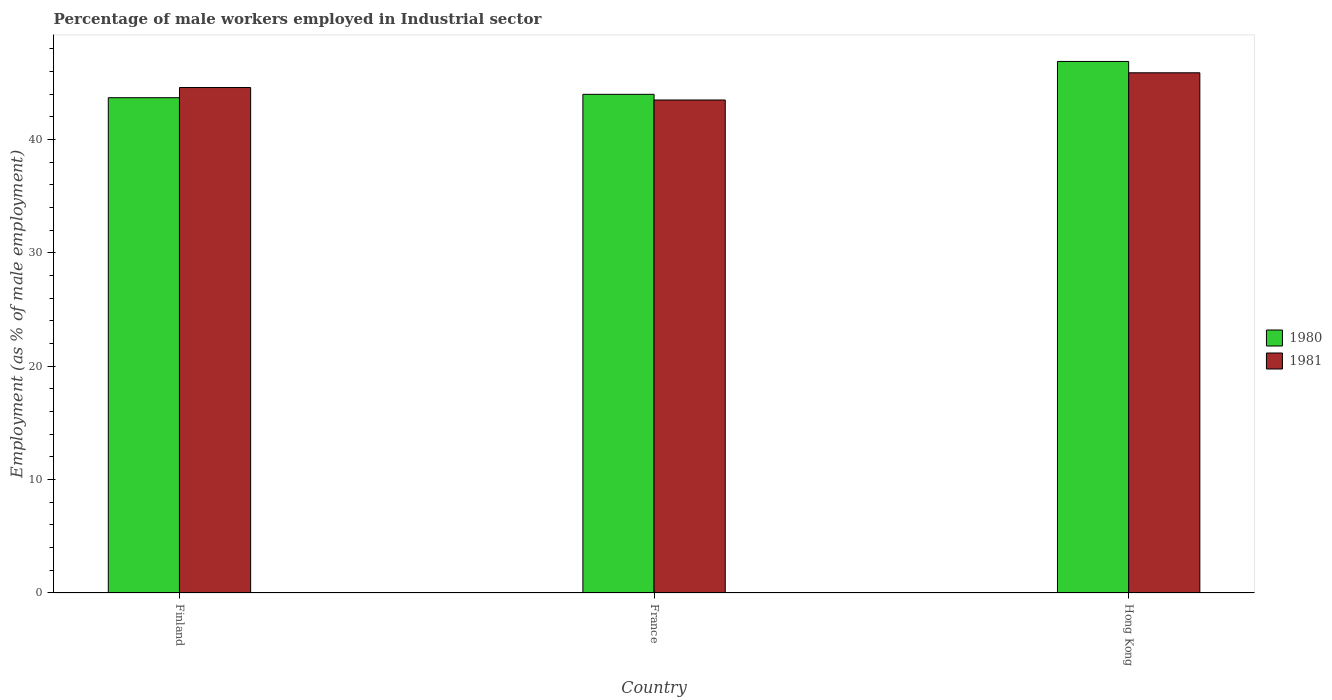How many groups of bars are there?
Your response must be concise. 3. Are the number of bars on each tick of the X-axis equal?
Your answer should be very brief. Yes. How many bars are there on the 3rd tick from the right?
Provide a succinct answer. 2. In how many cases, is the number of bars for a given country not equal to the number of legend labels?
Ensure brevity in your answer.  0. Across all countries, what is the maximum percentage of male workers employed in Industrial sector in 1981?
Offer a very short reply. 45.9. Across all countries, what is the minimum percentage of male workers employed in Industrial sector in 1980?
Your answer should be very brief. 43.7. In which country was the percentage of male workers employed in Industrial sector in 1981 maximum?
Your answer should be compact. Hong Kong. What is the total percentage of male workers employed in Industrial sector in 1980 in the graph?
Keep it short and to the point. 134.6. What is the difference between the percentage of male workers employed in Industrial sector in 1980 in France and that in Hong Kong?
Your response must be concise. -2.9. What is the difference between the percentage of male workers employed in Industrial sector in 1980 in France and the percentage of male workers employed in Industrial sector in 1981 in Finland?
Ensure brevity in your answer.  -0.6. What is the average percentage of male workers employed in Industrial sector in 1981 per country?
Your response must be concise. 44.67. What is the difference between the percentage of male workers employed in Industrial sector of/in 1980 and percentage of male workers employed in Industrial sector of/in 1981 in France?
Offer a very short reply. 0.5. In how many countries, is the percentage of male workers employed in Industrial sector in 1981 greater than 16 %?
Provide a succinct answer. 3. What is the ratio of the percentage of male workers employed in Industrial sector in 1981 in France to that in Hong Kong?
Your answer should be very brief. 0.95. What is the difference between the highest and the second highest percentage of male workers employed in Industrial sector in 1981?
Make the answer very short. -1.1. What is the difference between the highest and the lowest percentage of male workers employed in Industrial sector in 1980?
Offer a very short reply. 3.2. What does the 1st bar from the right in Finland represents?
Make the answer very short. 1981. How many bars are there?
Ensure brevity in your answer.  6. How many countries are there in the graph?
Ensure brevity in your answer.  3. What is the difference between two consecutive major ticks on the Y-axis?
Ensure brevity in your answer.  10. Are the values on the major ticks of Y-axis written in scientific E-notation?
Your answer should be compact. No. Does the graph contain grids?
Offer a very short reply. No. Where does the legend appear in the graph?
Provide a succinct answer. Center right. How many legend labels are there?
Give a very brief answer. 2. What is the title of the graph?
Your response must be concise. Percentage of male workers employed in Industrial sector. What is the label or title of the X-axis?
Offer a very short reply. Country. What is the label or title of the Y-axis?
Your answer should be compact. Employment (as % of male employment). What is the Employment (as % of male employment) of 1980 in Finland?
Give a very brief answer. 43.7. What is the Employment (as % of male employment) in 1981 in Finland?
Your answer should be very brief. 44.6. What is the Employment (as % of male employment) of 1980 in France?
Your answer should be very brief. 44. What is the Employment (as % of male employment) of 1981 in France?
Your answer should be very brief. 43.5. What is the Employment (as % of male employment) in 1980 in Hong Kong?
Your response must be concise. 46.9. What is the Employment (as % of male employment) of 1981 in Hong Kong?
Your answer should be very brief. 45.9. Across all countries, what is the maximum Employment (as % of male employment) in 1980?
Provide a short and direct response. 46.9. Across all countries, what is the maximum Employment (as % of male employment) of 1981?
Your answer should be compact. 45.9. Across all countries, what is the minimum Employment (as % of male employment) of 1980?
Keep it short and to the point. 43.7. Across all countries, what is the minimum Employment (as % of male employment) of 1981?
Offer a terse response. 43.5. What is the total Employment (as % of male employment) of 1980 in the graph?
Make the answer very short. 134.6. What is the total Employment (as % of male employment) of 1981 in the graph?
Make the answer very short. 134. What is the difference between the Employment (as % of male employment) of 1980 in Finland and that in France?
Provide a short and direct response. -0.3. What is the difference between the Employment (as % of male employment) in 1981 in Finland and that in France?
Your answer should be very brief. 1.1. What is the difference between the Employment (as % of male employment) of 1980 in Finland and that in Hong Kong?
Your answer should be compact. -3.2. What is the difference between the Employment (as % of male employment) in 1980 in Finland and the Employment (as % of male employment) in 1981 in France?
Offer a terse response. 0.2. What is the average Employment (as % of male employment) in 1980 per country?
Keep it short and to the point. 44.87. What is the average Employment (as % of male employment) in 1981 per country?
Your response must be concise. 44.67. What is the ratio of the Employment (as % of male employment) of 1981 in Finland to that in France?
Offer a terse response. 1.03. What is the ratio of the Employment (as % of male employment) in 1980 in Finland to that in Hong Kong?
Provide a succinct answer. 0.93. What is the ratio of the Employment (as % of male employment) in 1981 in Finland to that in Hong Kong?
Offer a very short reply. 0.97. What is the ratio of the Employment (as % of male employment) in 1980 in France to that in Hong Kong?
Provide a succinct answer. 0.94. What is the ratio of the Employment (as % of male employment) in 1981 in France to that in Hong Kong?
Give a very brief answer. 0.95. 